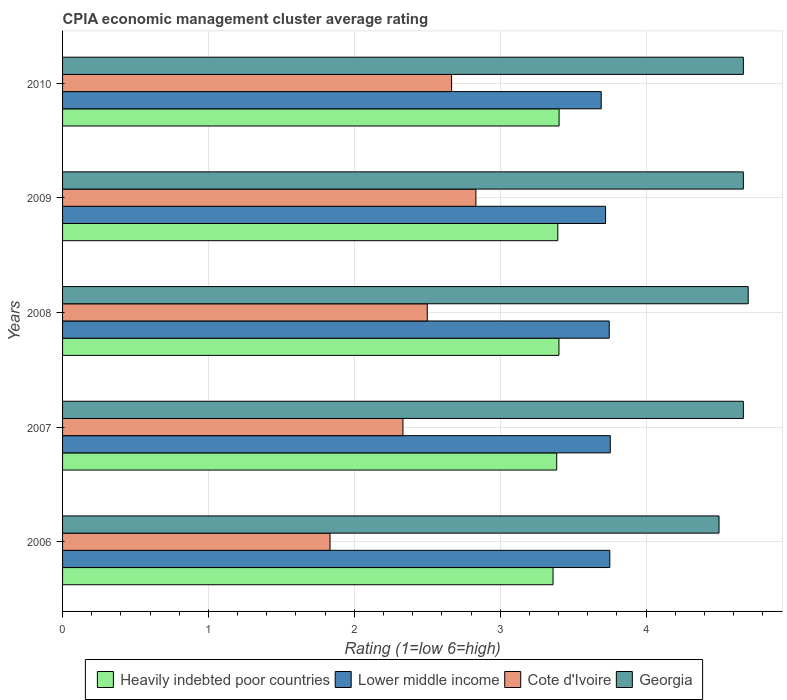How many different coloured bars are there?
Your answer should be very brief. 4. How many groups of bars are there?
Ensure brevity in your answer.  5. Are the number of bars per tick equal to the number of legend labels?
Make the answer very short. Yes. What is the CPIA rating in Georgia in 2006?
Provide a succinct answer. 4.5. Across all years, what is the minimum CPIA rating in Heavily indebted poor countries?
Offer a very short reply. 3.36. In which year was the CPIA rating in Lower middle income maximum?
Your answer should be very brief. 2007. What is the total CPIA rating in Cote d'Ivoire in the graph?
Make the answer very short. 12.17. What is the difference between the CPIA rating in Heavily indebted poor countries in 2008 and that in 2009?
Your answer should be compact. 0.01. What is the difference between the CPIA rating in Heavily indebted poor countries in 2008 and the CPIA rating in Cote d'Ivoire in 2007?
Your answer should be very brief. 1.07. What is the average CPIA rating in Heavily indebted poor countries per year?
Your answer should be very brief. 3.39. In the year 2008, what is the difference between the CPIA rating in Heavily indebted poor countries and CPIA rating in Cote d'Ivoire?
Keep it short and to the point. 0.9. What is the ratio of the CPIA rating in Georgia in 2006 to that in 2007?
Keep it short and to the point. 0.96. Is the CPIA rating in Georgia in 2007 less than that in 2009?
Ensure brevity in your answer.  No. Is the difference between the CPIA rating in Heavily indebted poor countries in 2007 and 2009 greater than the difference between the CPIA rating in Cote d'Ivoire in 2007 and 2009?
Offer a very short reply. Yes. What is the difference between the highest and the second highest CPIA rating in Georgia?
Make the answer very short. 0.03. What is the difference between the highest and the lowest CPIA rating in Lower middle income?
Your answer should be compact. 0.06. Is it the case that in every year, the sum of the CPIA rating in Cote d'Ivoire and CPIA rating in Georgia is greater than the sum of CPIA rating in Lower middle income and CPIA rating in Heavily indebted poor countries?
Offer a terse response. Yes. What does the 1st bar from the top in 2007 represents?
Provide a succinct answer. Georgia. What does the 2nd bar from the bottom in 2010 represents?
Make the answer very short. Lower middle income. Is it the case that in every year, the sum of the CPIA rating in Lower middle income and CPIA rating in Cote d'Ivoire is greater than the CPIA rating in Heavily indebted poor countries?
Provide a succinct answer. Yes. How many bars are there?
Give a very brief answer. 20. Are all the bars in the graph horizontal?
Provide a short and direct response. Yes. What is the difference between two consecutive major ticks on the X-axis?
Offer a terse response. 1. Are the values on the major ticks of X-axis written in scientific E-notation?
Offer a very short reply. No. Does the graph contain any zero values?
Ensure brevity in your answer.  No. Where does the legend appear in the graph?
Make the answer very short. Bottom center. How are the legend labels stacked?
Your answer should be compact. Horizontal. What is the title of the graph?
Make the answer very short. CPIA economic management cluster average rating. Does "Isle of Man" appear as one of the legend labels in the graph?
Offer a terse response. No. What is the label or title of the X-axis?
Keep it short and to the point. Rating (1=low 6=high). What is the label or title of the Y-axis?
Keep it short and to the point. Years. What is the Rating (1=low 6=high) of Heavily indebted poor countries in 2006?
Give a very brief answer. 3.36. What is the Rating (1=low 6=high) in Lower middle income in 2006?
Provide a succinct answer. 3.75. What is the Rating (1=low 6=high) of Cote d'Ivoire in 2006?
Offer a very short reply. 1.83. What is the Rating (1=low 6=high) in Georgia in 2006?
Offer a terse response. 4.5. What is the Rating (1=low 6=high) of Heavily indebted poor countries in 2007?
Ensure brevity in your answer.  3.39. What is the Rating (1=low 6=high) in Lower middle income in 2007?
Offer a terse response. 3.75. What is the Rating (1=low 6=high) in Cote d'Ivoire in 2007?
Provide a succinct answer. 2.33. What is the Rating (1=low 6=high) of Georgia in 2007?
Keep it short and to the point. 4.67. What is the Rating (1=low 6=high) in Heavily indebted poor countries in 2008?
Your answer should be compact. 3.4. What is the Rating (1=low 6=high) in Lower middle income in 2008?
Make the answer very short. 3.75. What is the Rating (1=low 6=high) in Heavily indebted poor countries in 2009?
Offer a very short reply. 3.39. What is the Rating (1=low 6=high) of Lower middle income in 2009?
Ensure brevity in your answer.  3.72. What is the Rating (1=low 6=high) of Cote d'Ivoire in 2009?
Provide a short and direct response. 2.83. What is the Rating (1=low 6=high) in Georgia in 2009?
Your answer should be very brief. 4.67. What is the Rating (1=low 6=high) in Heavily indebted poor countries in 2010?
Keep it short and to the point. 3.4. What is the Rating (1=low 6=high) of Lower middle income in 2010?
Your answer should be very brief. 3.69. What is the Rating (1=low 6=high) of Cote d'Ivoire in 2010?
Provide a short and direct response. 2.67. What is the Rating (1=low 6=high) in Georgia in 2010?
Provide a succinct answer. 4.67. Across all years, what is the maximum Rating (1=low 6=high) in Heavily indebted poor countries?
Give a very brief answer. 3.4. Across all years, what is the maximum Rating (1=low 6=high) in Lower middle income?
Make the answer very short. 3.75. Across all years, what is the maximum Rating (1=low 6=high) of Cote d'Ivoire?
Keep it short and to the point. 2.83. Across all years, what is the minimum Rating (1=low 6=high) in Heavily indebted poor countries?
Keep it short and to the point. 3.36. Across all years, what is the minimum Rating (1=low 6=high) in Lower middle income?
Your answer should be very brief. 3.69. Across all years, what is the minimum Rating (1=low 6=high) in Cote d'Ivoire?
Ensure brevity in your answer.  1.83. What is the total Rating (1=low 6=high) in Heavily indebted poor countries in the graph?
Your answer should be very brief. 16.95. What is the total Rating (1=low 6=high) in Lower middle income in the graph?
Offer a very short reply. 18.67. What is the total Rating (1=low 6=high) in Cote d'Ivoire in the graph?
Offer a terse response. 12.17. What is the total Rating (1=low 6=high) in Georgia in the graph?
Give a very brief answer. 23.2. What is the difference between the Rating (1=low 6=high) of Heavily indebted poor countries in 2006 and that in 2007?
Provide a short and direct response. -0.03. What is the difference between the Rating (1=low 6=high) in Lower middle income in 2006 and that in 2007?
Keep it short and to the point. -0. What is the difference between the Rating (1=low 6=high) in Cote d'Ivoire in 2006 and that in 2007?
Your answer should be very brief. -0.5. What is the difference between the Rating (1=low 6=high) in Georgia in 2006 and that in 2007?
Your answer should be very brief. -0.17. What is the difference between the Rating (1=low 6=high) of Heavily indebted poor countries in 2006 and that in 2008?
Your answer should be compact. -0.04. What is the difference between the Rating (1=low 6=high) of Lower middle income in 2006 and that in 2008?
Give a very brief answer. 0. What is the difference between the Rating (1=low 6=high) of Heavily indebted poor countries in 2006 and that in 2009?
Keep it short and to the point. -0.03. What is the difference between the Rating (1=low 6=high) of Lower middle income in 2006 and that in 2009?
Give a very brief answer. 0.03. What is the difference between the Rating (1=low 6=high) of Cote d'Ivoire in 2006 and that in 2009?
Offer a terse response. -1. What is the difference between the Rating (1=low 6=high) of Heavily indebted poor countries in 2006 and that in 2010?
Give a very brief answer. -0.04. What is the difference between the Rating (1=low 6=high) in Lower middle income in 2006 and that in 2010?
Keep it short and to the point. 0.06. What is the difference between the Rating (1=low 6=high) of Cote d'Ivoire in 2006 and that in 2010?
Your answer should be compact. -0.83. What is the difference between the Rating (1=low 6=high) in Georgia in 2006 and that in 2010?
Ensure brevity in your answer.  -0.17. What is the difference between the Rating (1=low 6=high) of Heavily indebted poor countries in 2007 and that in 2008?
Give a very brief answer. -0.02. What is the difference between the Rating (1=low 6=high) in Lower middle income in 2007 and that in 2008?
Make the answer very short. 0.01. What is the difference between the Rating (1=low 6=high) in Cote d'Ivoire in 2007 and that in 2008?
Offer a terse response. -0.17. What is the difference between the Rating (1=low 6=high) of Georgia in 2007 and that in 2008?
Provide a short and direct response. -0.03. What is the difference between the Rating (1=low 6=high) of Heavily indebted poor countries in 2007 and that in 2009?
Provide a succinct answer. -0.01. What is the difference between the Rating (1=low 6=high) of Lower middle income in 2007 and that in 2009?
Ensure brevity in your answer.  0.03. What is the difference between the Rating (1=low 6=high) in Georgia in 2007 and that in 2009?
Provide a succinct answer. 0. What is the difference between the Rating (1=low 6=high) of Heavily indebted poor countries in 2007 and that in 2010?
Keep it short and to the point. -0.02. What is the difference between the Rating (1=low 6=high) of Lower middle income in 2007 and that in 2010?
Ensure brevity in your answer.  0.06. What is the difference between the Rating (1=low 6=high) in Cote d'Ivoire in 2007 and that in 2010?
Provide a short and direct response. -0.33. What is the difference between the Rating (1=low 6=high) in Georgia in 2007 and that in 2010?
Provide a short and direct response. 0. What is the difference between the Rating (1=low 6=high) of Heavily indebted poor countries in 2008 and that in 2009?
Offer a terse response. 0.01. What is the difference between the Rating (1=low 6=high) in Lower middle income in 2008 and that in 2009?
Provide a succinct answer. 0.03. What is the difference between the Rating (1=low 6=high) in Cote d'Ivoire in 2008 and that in 2009?
Your answer should be compact. -0.33. What is the difference between the Rating (1=low 6=high) in Georgia in 2008 and that in 2009?
Your answer should be very brief. 0.03. What is the difference between the Rating (1=low 6=high) of Heavily indebted poor countries in 2008 and that in 2010?
Make the answer very short. -0. What is the difference between the Rating (1=low 6=high) in Lower middle income in 2008 and that in 2010?
Offer a terse response. 0.06. What is the difference between the Rating (1=low 6=high) in Cote d'Ivoire in 2008 and that in 2010?
Your answer should be compact. -0.17. What is the difference between the Rating (1=low 6=high) of Georgia in 2008 and that in 2010?
Provide a succinct answer. 0.03. What is the difference between the Rating (1=low 6=high) of Heavily indebted poor countries in 2009 and that in 2010?
Provide a succinct answer. -0.01. What is the difference between the Rating (1=low 6=high) in Lower middle income in 2009 and that in 2010?
Provide a succinct answer. 0.03. What is the difference between the Rating (1=low 6=high) in Heavily indebted poor countries in 2006 and the Rating (1=low 6=high) in Lower middle income in 2007?
Your response must be concise. -0.39. What is the difference between the Rating (1=low 6=high) in Heavily indebted poor countries in 2006 and the Rating (1=low 6=high) in Cote d'Ivoire in 2007?
Your response must be concise. 1.03. What is the difference between the Rating (1=low 6=high) of Heavily indebted poor countries in 2006 and the Rating (1=low 6=high) of Georgia in 2007?
Offer a very short reply. -1.3. What is the difference between the Rating (1=low 6=high) of Lower middle income in 2006 and the Rating (1=low 6=high) of Cote d'Ivoire in 2007?
Give a very brief answer. 1.42. What is the difference between the Rating (1=low 6=high) in Lower middle income in 2006 and the Rating (1=low 6=high) in Georgia in 2007?
Make the answer very short. -0.92. What is the difference between the Rating (1=low 6=high) in Cote d'Ivoire in 2006 and the Rating (1=low 6=high) in Georgia in 2007?
Provide a short and direct response. -2.83. What is the difference between the Rating (1=low 6=high) of Heavily indebted poor countries in 2006 and the Rating (1=low 6=high) of Lower middle income in 2008?
Give a very brief answer. -0.39. What is the difference between the Rating (1=low 6=high) in Heavily indebted poor countries in 2006 and the Rating (1=low 6=high) in Cote d'Ivoire in 2008?
Give a very brief answer. 0.86. What is the difference between the Rating (1=low 6=high) in Heavily indebted poor countries in 2006 and the Rating (1=low 6=high) in Georgia in 2008?
Keep it short and to the point. -1.34. What is the difference between the Rating (1=low 6=high) in Lower middle income in 2006 and the Rating (1=low 6=high) in Cote d'Ivoire in 2008?
Ensure brevity in your answer.  1.25. What is the difference between the Rating (1=low 6=high) in Lower middle income in 2006 and the Rating (1=low 6=high) in Georgia in 2008?
Your answer should be compact. -0.95. What is the difference between the Rating (1=low 6=high) of Cote d'Ivoire in 2006 and the Rating (1=low 6=high) of Georgia in 2008?
Provide a succinct answer. -2.87. What is the difference between the Rating (1=low 6=high) in Heavily indebted poor countries in 2006 and the Rating (1=low 6=high) in Lower middle income in 2009?
Your answer should be very brief. -0.36. What is the difference between the Rating (1=low 6=high) of Heavily indebted poor countries in 2006 and the Rating (1=low 6=high) of Cote d'Ivoire in 2009?
Ensure brevity in your answer.  0.53. What is the difference between the Rating (1=low 6=high) of Heavily indebted poor countries in 2006 and the Rating (1=low 6=high) of Georgia in 2009?
Your answer should be compact. -1.3. What is the difference between the Rating (1=low 6=high) of Lower middle income in 2006 and the Rating (1=low 6=high) of Cote d'Ivoire in 2009?
Provide a short and direct response. 0.92. What is the difference between the Rating (1=low 6=high) of Lower middle income in 2006 and the Rating (1=low 6=high) of Georgia in 2009?
Your answer should be very brief. -0.92. What is the difference between the Rating (1=low 6=high) of Cote d'Ivoire in 2006 and the Rating (1=low 6=high) of Georgia in 2009?
Ensure brevity in your answer.  -2.83. What is the difference between the Rating (1=low 6=high) of Heavily indebted poor countries in 2006 and the Rating (1=low 6=high) of Lower middle income in 2010?
Make the answer very short. -0.33. What is the difference between the Rating (1=low 6=high) of Heavily indebted poor countries in 2006 and the Rating (1=low 6=high) of Cote d'Ivoire in 2010?
Provide a succinct answer. 0.7. What is the difference between the Rating (1=low 6=high) in Heavily indebted poor countries in 2006 and the Rating (1=low 6=high) in Georgia in 2010?
Give a very brief answer. -1.3. What is the difference between the Rating (1=low 6=high) of Lower middle income in 2006 and the Rating (1=low 6=high) of Cote d'Ivoire in 2010?
Offer a terse response. 1.08. What is the difference between the Rating (1=low 6=high) in Lower middle income in 2006 and the Rating (1=low 6=high) in Georgia in 2010?
Make the answer very short. -0.92. What is the difference between the Rating (1=low 6=high) in Cote d'Ivoire in 2006 and the Rating (1=low 6=high) in Georgia in 2010?
Give a very brief answer. -2.83. What is the difference between the Rating (1=low 6=high) in Heavily indebted poor countries in 2007 and the Rating (1=low 6=high) in Lower middle income in 2008?
Offer a terse response. -0.36. What is the difference between the Rating (1=low 6=high) in Heavily indebted poor countries in 2007 and the Rating (1=low 6=high) in Cote d'Ivoire in 2008?
Ensure brevity in your answer.  0.89. What is the difference between the Rating (1=low 6=high) of Heavily indebted poor countries in 2007 and the Rating (1=low 6=high) of Georgia in 2008?
Offer a very short reply. -1.31. What is the difference between the Rating (1=low 6=high) of Lower middle income in 2007 and the Rating (1=low 6=high) of Cote d'Ivoire in 2008?
Make the answer very short. 1.25. What is the difference between the Rating (1=low 6=high) in Lower middle income in 2007 and the Rating (1=low 6=high) in Georgia in 2008?
Your response must be concise. -0.95. What is the difference between the Rating (1=low 6=high) in Cote d'Ivoire in 2007 and the Rating (1=low 6=high) in Georgia in 2008?
Offer a very short reply. -2.37. What is the difference between the Rating (1=low 6=high) in Heavily indebted poor countries in 2007 and the Rating (1=low 6=high) in Lower middle income in 2009?
Your answer should be very brief. -0.33. What is the difference between the Rating (1=low 6=high) of Heavily indebted poor countries in 2007 and the Rating (1=low 6=high) of Cote d'Ivoire in 2009?
Offer a terse response. 0.55. What is the difference between the Rating (1=low 6=high) of Heavily indebted poor countries in 2007 and the Rating (1=low 6=high) of Georgia in 2009?
Give a very brief answer. -1.28. What is the difference between the Rating (1=low 6=high) in Lower middle income in 2007 and the Rating (1=low 6=high) in Cote d'Ivoire in 2009?
Provide a succinct answer. 0.92. What is the difference between the Rating (1=low 6=high) in Lower middle income in 2007 and the Rating (1=low 6=high) in Georgia in 2009?
Your response must be concise. -0.91. What is the difference between the Rating (1=low 6=high) of Cote d'Ivoire in 2007 and the Rating (1=low 6=high) of Georgia in 2009?
Offer a very short reply. -2.33. What is the difference between the Rating (1=low 6=high) in Heavily indebted poor countries in 2007 and the Rating (1=low 6=high) in Lower middle income in 2010?
Provide a short and direct response. -0.3. What is the difference between the Rating (1=low 6=high) in Heavily indebted poor countries in 2007 and the Rating (1=low 6=high) in Cote d'Ivoire in 2010?
Make the answer very short. 0.72. What is the difference between the Rating (1=low 6=high) in Heavily indebted poor countries in 2007 and the Rating (1=low 6=high) in Georgia in 2010?
Your answer should be very brief. -1.28. What is the difference between the Rating (1=low 6=high) of Lower middle income in 2007 and the Rating (1=low 6=high) of Cote d'Ivoire in 2010?
Offer a very short reply. 1.09. What is the difference between the Rating (1=low 6=high) in Lower middle income in 2007 and the Rating (1=low 6=high) in Georgia in 2010?
Keep it short and to the point. -0.91. What is the difference between the Rating (1=low 6=high) in Cote d'Ivoire in 2007 and the Rating (1=low 6=high) in Georgia in 2010?
Your response must be concise. -2.33. What is the difference between the Rating (1=low 6=high) in Heavily indebted poor countries in 2008 and the Rating (1=low 6=high) in Lower middle income in 2009?
Provide a succinct answer. -0.32. What is the difference between the Rating (1=low 6=high) in Heavily indebted poor countries in 2008 and the Rating (1=low 6=high) in Cote d'Ivoire in 2009?
Make the answer very short. 0.57. What is the difference between the Rating (1=low 6=high) in Heavily indebted poor countries in 2008 and the Rating (1=low 6=high) in Georgia in 2009?
Keep it short and to the point. -1.26. What is the difference between the Rating (1=low 6=high) in Lower middle income in 2008 and the Rating (1=low 6=high) in Cote d'Ivoire in 2009?
Your response must be concise. 0.91. What is the difference between the Rating (1=low 6=high) in Lower middle income in 2008 and the Rating (1=low 6=high) in Georgia in 2009?
Your response must be concise. -0.92. What is the difference between the Rating (1=low 6=high) of Cote d'Ivoire in 2008 and the Rating (1=low 6=high) of Georgia in 2009?
Offer a very short reply. -2.17. What is the difference between the Rating (1=low 6=high) in Heavily indebted poor countries in 2008 and the Rating (1=low 6=high) in Lower middle income in 2010?
Make the answer very short. -0.29. What is the difference between the Rating (1=low 6=high) in Heavily indebted poor countries in 2008 and the Rating (1=low 6=high) in Cote d'Ivoire in 2010?
Offer a terse response. 0.74. What is the difference between the Rating (1=low 6=high) in Heavily indebted poor countries in 2008 and the Rating (1=low 6=high) in Georgia in 2010?
Your answer should be compact. -1.26. What is the difference between the Rating (1=low 6=high) in Lower middle income in 2008 and the Rating (1=low 6=high) in Cote d'Ivoire in 2010?
Make the answer very short. 1.08. What is the difference between the Rating (1=low 6=high) of Lower middle income in 2008 and the Rating (1=low 6=high) of Georgia in 2010?
Your answer should be compact. -0.92. What is the difference between the Rating (1=low 6=high) in Cote d'Ivoire in 2008 and the Rating (1=low 6=high) in Georgia in 2010?
Make the answer very short. -2.17. What is the difference between the Rating (1=low 6=high) in Heavily indebted poor countries in 2009 and the Rating (1=low 6=high) in Lower middle income in 2010?
Your response must be concise. -0.3. What is the difference between the Rating (1=low 6=high) in Heavily indebted poor countries in 2009 and the Rating (1=low 6=high) in Cote d'Ivoire in 2010?
Your response must be concise. 0.73. What is the difference between the Rating (1=low 6=high) of Heavily indebted poor countries in 2009 and the Rating (1=low 6=high) of Georgia in 2010?
Ensure brevity in your answer.  -1.27. What is the difference between the Rating (1=low 6=high) in Lower middle income in 2009 and the Rating (1=low 6=high) in Cote d'Ivoire in 2010?
Offer a terse response. 1.06. What is the difference between the Rating (1=low 6=high) of Lower middle income in 2009 and the Rating (1=low 6=high) of Georgia in 2010?
Your response must be concise. -0.94. What is the difference between the Rating (1=low 6=high) in Cote d'Ivoire in 2009 and the Rating (1=low 6=high) in Georgia in 2010?
Provide a succinct answer. -1.83. What is the average Rating (1=low 6=high) in Heavily indebted poor countries per year?
Ensure brevity in your answer.  3.39. What is the average Rating (1=low 6=high) in Lower middle income per year?
Your answer should be compact. 3.73. What is the average Rating (1=low 6=high) in Cote d'Ivoire per year?
Your answer should be compact. 2.43. What is the average Rating (1=low 6=high) in Georgia per year?
Make the answer very short. 4.64. In the year 2006, what is the difference between the Rating (1=low 6=high) in Heavily indebted poor countries and Rating (1=low 6=high) in Lower middle income?
Provide a succinct answer. -0.39. In the year 2006, what is the difference between the Rating (1=low 6=high) in Heavily indebted poor countries and Rating (1=low 6=high) in Cote d'Ivoire?
Provide a short and direct response. 1.53. In the year 2006, what is the difference between the Rating (1=low 6=high) of Heavily indebted poor countries and Rating (1=low 6=high) of Georgia?
Offer a terse response. -1.14. In the year 2006, what is the difference between the Rating (1=low 6=high) in Lower middle income and Rating (1=low 6=high) in Cote d'Ivoire?
Keep it short and to the point. 1.92. In the year 2006, what is the difference between the Rating (1=low 6=high) in Lower middle income and Rating (1=low 6=high) in Georgia?
Ensure brevity in your answer.  -0.75. In the year 2006, what is the difference between the Rating (1=low 6=high) of Cote d'Ivoire and Rating (1=low 6=high) of Georgia?
Your answer should be very brief. -2.67. In the year 2007, what is the difference between the Rating (1=low 6=high) of Heavily indebted poor countries and Rating (1=low 6=high) of Lower middle income?
Offer a terse response. -0.37. In the year 2007, what is the difference between the Rating (1=low 6=high) in Heavily indebted poor countries and Rating (1=low 6=high) in Cote d'Ivoire?
Provide a succinct answer. 1.05. In the year 2007, what is the difference between the Rating (1=low 6=high) in Heavily indebted poor countries and Rating (1=low 6=high) in Georgia?
Your answer should be compact. -1.28. In the year 2007, what is the difference between the Rating (1=low 6=high) of Lower middle income and Rating (1=low 6=high) of Cote d'Ivoire?
Provide a short and direct response. 1.42. In the year 2007, what is the difference between the Rating (1=low 6=high) in Lower middle income and Rating (1=low 6=high) in Georgia?
Provide a short and direct response. -0.91. In the year 2007, what is the difference between the Rating (1=low 6=high) of Cote d'Ivoire and Rating (1=low 6=high) of Georgia?
Make the answer very short. -2.33. In the year 2008, what is the difference between the Rating (1=low 6=high) of Heavily indebted poor countries and Rating (1=low 6=high) of Lower middle income?
Give a very brief answer. -0.34. In the year 2008, what is the difference between the Rating (1=low 6=high) in Heavily indebted poor countries and Rating (1=low 6=high) in Cote d'Ivoire?
Make the answer very short. 0.9. In the year 2008, what is the difference between the Rating (1=low 6=high) in Heavily indebted poor countries and Rating (1=low 6=high) in Georgia?
Provide a succinct answer. -1.3. In the year 2008, what is the difference between the Rating (1=low 6=high) in Lower middle income and Rating (1=low 6=high) in Cote d'Ivoire?
Your response must be concise. 1.25. In the year 2008, what is the difference between the Rating (1=low 6=high) in Lower middle income and Rating (1=low 6=high) in Georgia?
Your response must be concise. -0.95. In the year 2008, what is the difference between the Rating (1=low 6=high) in Cote d'Ivoire and Rating (1=low 6=high) in Georgia?
Make the answer very short. -2.2. In the year 2009, what is the difference between the Rating (1=low 6=high) in Heavily indebted poor countries and Rating (1=low 6=high) in Lower middle income?
Give a very brief answer. -0.33. In the year 2009, what is the difference between the Rating (1=low 6=high) in Heavily indebted poor countries and Rating (1=low 6=high) in Cote d'Ivoire?
Make the answer very short. 0.56. In the year 2009, what is the difference between the Rating (1=low 6=high) in Heavily indebted poor countries and Rating (1=low 6=high) in Georgia?
Provide a short and direct response. -1.27. In the year 2009, what is the difference between the Rating (1=low 6=high) in Lower middle income and Rating (1=low 6=high) in Georgia?
Your response must be concise. -0.94. In the year 2009, what is the difference between the Rating (1=low 6=high) in Cote d'Ivoire and Rating (1=low 6=high) in Georgia?
Keep it short and to the point. -1.83. In the year 2010, what is the difference between the Rating (1=low 6=high) in Heavily indebted poor countries and Rating (1=low 6=high) in Lower middle income?
Your answer should be compact. -0.29. In the year 2010, what is the difference between the Rating (1=low 6=high) in Heavily indebted poor countries and Rating (1=low 6=high) in Cote d'Ivoire?
Offer a very short reply. 0.74. In the year 2010, what is the difference between the Rating (1=low 6=high) in Heavily indebted poor countries and Rating (1=low 6=high) in Georgia?
Ensure brevity in your answer.  -1.26. In the year 2010, what is the difference between the Rating (1=low 6=high) of Lower middle income and Rating (1=low 6=high) of Cote d'Ivoire?
Give a very brief answer. 1.03. In the year 2010, what is the difference between the Rating (1=low 6=high) in Lower middle income and Rating (1=low 6=high) in Georgia?
Make the answer very short. -0.97. What is the ratio of the Rating (1=low 6=high) in Heavily indebted poor countries in 2006 to that in 2007?
Offer a terse response. 0.99. What is the ratio of the Rating (1=low 6=high) of Cote d'Ivoire in 2006 to that in 2007?
Your answer should be very brief. 0.79. What is the ratio of the Rating (1=low 6=high) in Georgia in 2006 to that in 2007?
Provide a short and direct response. 0.96. What is the ratio of the Rating (1=low 6=high) in Cote d'Ivoire in 2006 to that in 2008?
Keep it short and to the point. 0.73. What is the ratio of the Rating (1=low 6=high) in Georgia in 2006 to that in 2008?
Keep it short and to the point. 0.96. What is the ratio of the Rating (1=low 6=high) in Heavily indebted poor countries in 2006 to that in 2009?
Ensure brevity in your answer.  0.99. What is the ratio of the Rating (1=low 6=high) of Cote d'Ivoire in 2006 to that in 2009?
Ensure brevity in your answer.  0.65. What is the ratio of the Rating (1=low 6=high) in Heavily indebted poor countries in 2006 to that in 2010?
Provide a short and direct response. 0.99. What is the ratio of the Rating (1=low 6=high) in Cote d'Ivoire in 2006 to that in 2010?
Provide a succinct answer. 0.69. What is the ratio of the Rating (1=low 6=high) in Georgia in 2006 to that in 2010?
Offer a terse response. 0.96. What is the ratio of the Rating (1=low 6=high) in Lower middle income in 2007 to that in 2008?
Give a very brief answer. 1. What is the ratio of the Rating (1=low 6=high) of Cote d'Ivoire in 2007 to that in 2008?
Ensure brevity in your answer.  0.93. What is the ratio of the Rating (1=low 6=high) of Georgia in 2007 to that in 2008?
Ensure brevity in your answer.  0.99. What is the ratio of the Rating (1=low 6=high) of Heavily indebted poor countries in 2007 to that in 2009?
Offer a very short reply. 1. What is the ratio of the Rating (1=low 6=high) of Lower middle income in 2007 to that in 2009?
Keep it short and to the point. 1.01. What is the ratio of the Rating (1=low 6=high) of Cote d'Ivoire in 2007 to that in 2009?
Your answer should be compact. 0.82. What is the ratio of the Rating (1=low 6=high) of Lower middle income in 2007 to that in 2010?
Provide a short and direct response. 1.02. What is the ratio of the Rating (1=low 6=high) in Lower middle income in 2008 to that in 2009?
Ensure brevity in your answer.  1.01. What is the ratio of the Rating (1=low 6=high) of Cote d'Ivoire in 2008 to that in 2009?
Offer a very short reply. 0.88. What is the ratio of the Rating (1=low 6=high) in Georgia in 2008 to that in 2009?
Provide a succinct answer. 1.01. What is the ratio of the Rating (1=low 6=high) of Lower middle income in 2008 to that in 2010?
Give a very brief answer. 1.01. What is the ratio of the Rating (1=low 6=high) of Cote d'Ivoire in 2008 to that in 2010?
Offer a terse response. 0.94. What is the ratio of the Rating (1=low 6=high) of Georgia in 2008 to that in 2010?
Your answer should be compact. 1.01. What is the ratio of the Rating (1=low 6=high) of Heavily indebted poor countries in 2009 to that in 2010?
Provide a short and direct response. 1. What is the ratio of the Rating (1=low 6=high) of Cote d'Ivoire in 2009 to that in 2010?
Your answer should be very brief. 1.06. What is the difference between the highest and the second highest Rating (1=low 6=high) of Heavily indebted poor countries?
Your answer should be very brief. 0. What is the difference between the highest and the second highest Rating (1=low 6=high) of Lower middle income?
Your answer should be compact. 0. What is the difference between the highest and the second highest Rating (1=low 6=high) of Cote d'Ivoire?
Offer a very short reply. 0.17. What is the difference between the highest and the lowest Rating (1=low 6=high) in Heavily indebted poor countries?
Your answer should be compact. 0.04. What is the difference between the highest and the lowest Rating (1=low 6=high) of Lower middle income?
Ensure brevity in your answer.  0.06. What is the difference between the highest and the lowest Rating (1=low 6=high) in Cote d'Ivoire?
Your response must be concise. 1. 